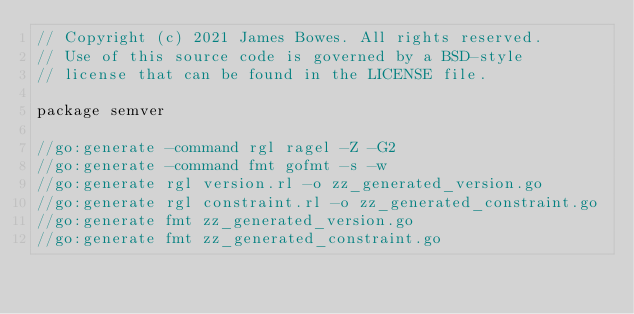Convert code to text. <code><loc_0><loc_0><loc_500><loc_500><_Go_>// Copyright (c) 2021 James Bowes. All rights reserved.
// Use of this source code is governed by a BSD-style
// license that can be found in the LICENSE file.

package semver

//go:generate -command rgl ragel -Z -G2
//go:generate -command fmt gofmt -s -w
//go:generate rgl version.rl -o zz_generated_version.go
//go:generate rgl constraint.rl -o zz_generated_constraint.go
//go:generate fmt zz_generated_version.go
//go:generate fmt zz_generated_constraint.go
</code> 